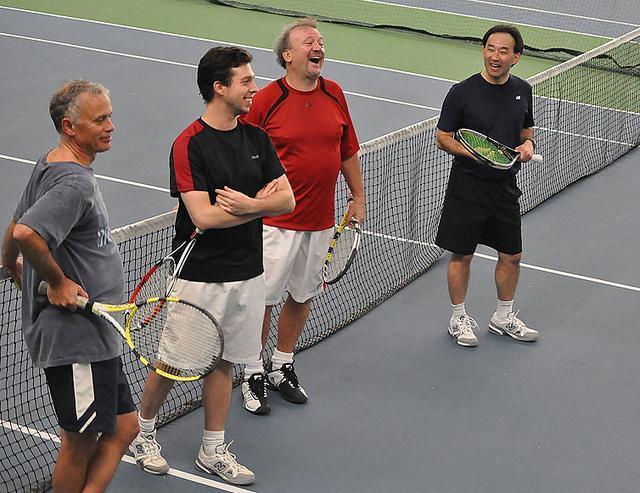How many men have tennis rackets?
Give a very brief answer. 4. How many men are wearing white shorts?
Give a very brief answer. 2. How many people are in the photo?
Give a very brief answer. 4. How many elephants are standing there?
Give a very brief answer. 0. 